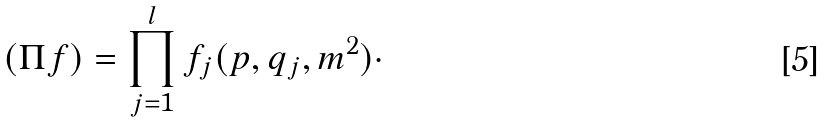Convert formula to latex. <formula><loc_0><loc_0><loc_500><loc_500>( \Pi f ) = \prod _ { j = 1 } ^ { l } f _ { j } ( p , q _ { j } , m ^ { 2 } ) \cdot</formula> 